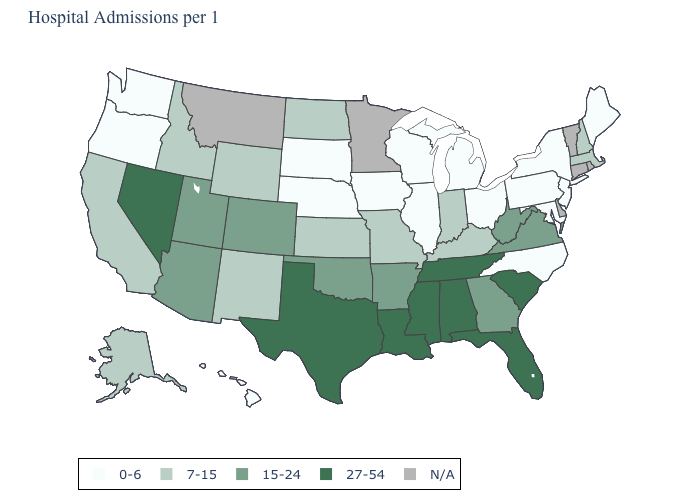How many symbols are there in the legend?
Quick response, please. 5. Which states hav the highest value in the MidWest?
Be succinct. Indiana, Kansas, Missouri, North Dakota. What is the value of Nebraska?
Quick response, please. 0-6. Name the states that have a value in the range 27-54?
Answer briefly. Alabama, Florida, Louisiana, Mississippi, Nevada, South Carolina, Tennessee, Texas. Among the states that border Texas , does Oklahoma have the highest value?
Short answer required. No. What is the value of Virginia?
Write a very short answer. 15-24. How many symbols are there in the legend?
Write a very short answer. 5. What is the value of Vermont?
Short answer required. N/A. Name the states that have a value in the range 7-15?
Quick response, please. Alaska, California, Idaho, Indiana, Kansas, Kentucky, Massachusetts, Missouri, New Hampshire, New Mexico, North Dakota, Wyoming. What is the highest value in the Northeast ?
Concise answer only. 7-15. What is the value of Wisconsin?
Be succinct. 0-6. Does the first symbol in the legend represent the smallest category?
Give a very brief answer. Yes. What is the lowest value in the MidWest?
Write a very short answer. 0-6. Name the states that have a value in the range 0-6?
Keep it brief. Hawaii, Illinois, Iowa, Maine, Maryland, Michigan, Nebraska, New Jersey, New York, North Carolina, Ohio, Oregon, Pennsylvania, South Dakota, Washington, Wisconsin. 